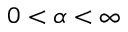<formula> <loc_0><loc_0><loc_500><loc_500>0 < \alpha < \infty</formula> 